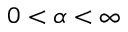<formula> <loc_0><loc_0><loc_500><loc_500>0 < \alpha < \infty</formula> 